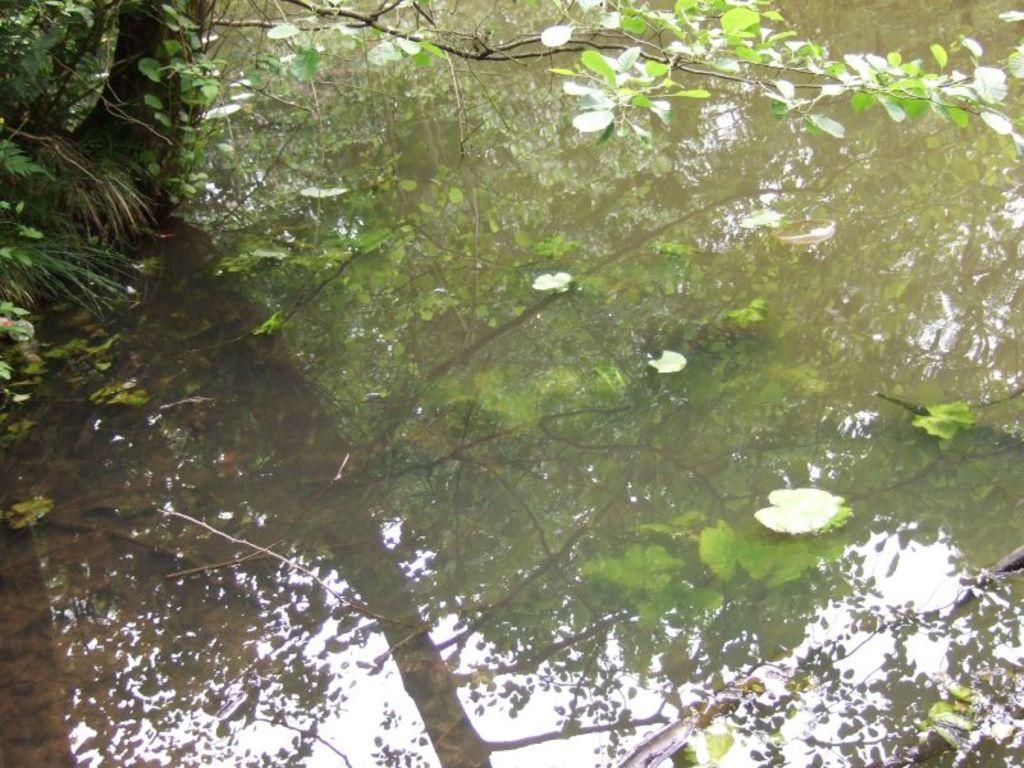Describe this image in one or two sentences. In the picture there is a water surface and there is a reflection of a tree can be seen on the water surface. 